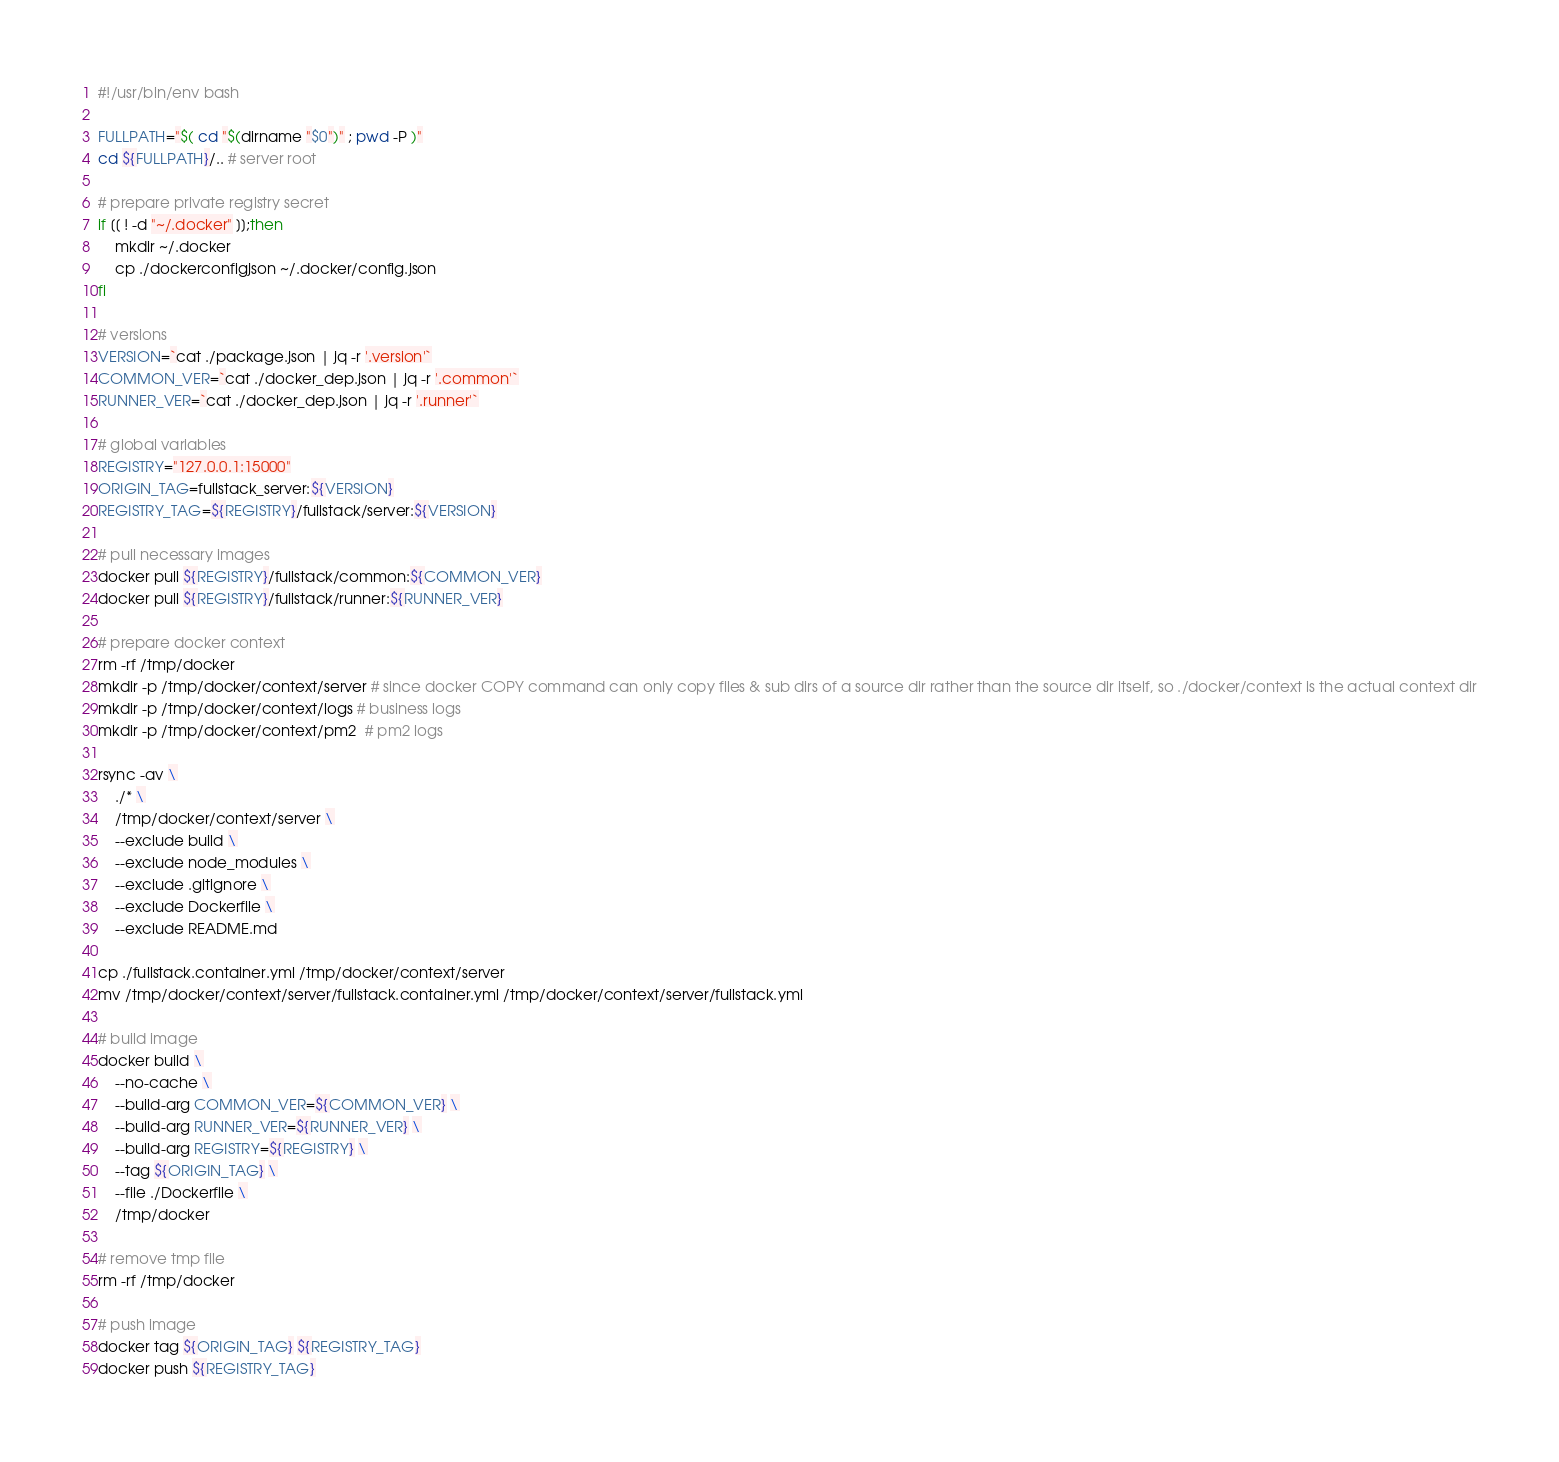Convert code to text. <code><loc_0><loc_0><loc_500><loc_500><_Bash_>#!/usr/bin/env bash

FULLPATH="$( cd "$(dirname "$0")" ; pwd -P )"
cd ${FULLPATH}/.. # server root

# prepare private registry secret
if [[ ! -d "~/.docker" ]];then
    mkdir ~/.docker
    cp ./dockerconfigjson ~/.docker/config.json
fi

# versions
VERSION=`cat ./package.json | jq -r '.version'`
COMMON_VER=`cat ./docker_dep.json | jq -r '.common'`
RUNNER_VER=`cat ./docker_dep.json | jq -r '.runner'`

# global variables
REGISTRY="127.0.0.1:15000"
ORIGIN_TAG=fullstack_server:${VERSION}
REGISTRY_TAG=${REGISTRY}/fullstack/server:${VERSION}

# pull necessary images
docker pull ${REGISTRY}/fullstack/common:${COMMON_VER}
docker pull ${REGISTRY}/fullstack/runner:${RUNNER_VER}

# prepare docker context
rm -rf /tmp/docker
mkdir -p /tmp/docker/context/server # since docker COPY command can only copy files & sub dirs of a source dir rather than the source dir itself, so ./docker/context is the actual context dir
mkdir -p /tmp/docker/context/logs # business logs
mkdir -p /tmp/docker/context/pm2  # pm2 logs

rsync -av \
    ./* \
    /tmp/docker/context/server \
    --exclude build \
    --exclude node_modules \
    --exclude .gitignore \
    --exclude Dockerfile \
    --exclude README.md

cp ./fullstack.container.yml /tmp/docker/context/server
mv /tmp/docker/context/server/fullstack.container.yml /tmp/docker/context/server/fullstack.yml

# build image
docker build \
    --no-cache \
    --build-arg COMMON_VER=${COMMON_VER} \
    --build-arg RUNNER_VER=${RUNNER_VER} \
    --build-arg REGISTRY=${REGISTRY} \
    --tag ${ORIGIN_TAG} \
    --file ./Dockerfile \
    /tmp/docker

# remove tmp file
rm -rf /tmp/docker

# push image
docker tag ${ORIGIN_TAG} ${REGISTRY_TAG}
docker push ${REGISTRY_TAG}
</code> 